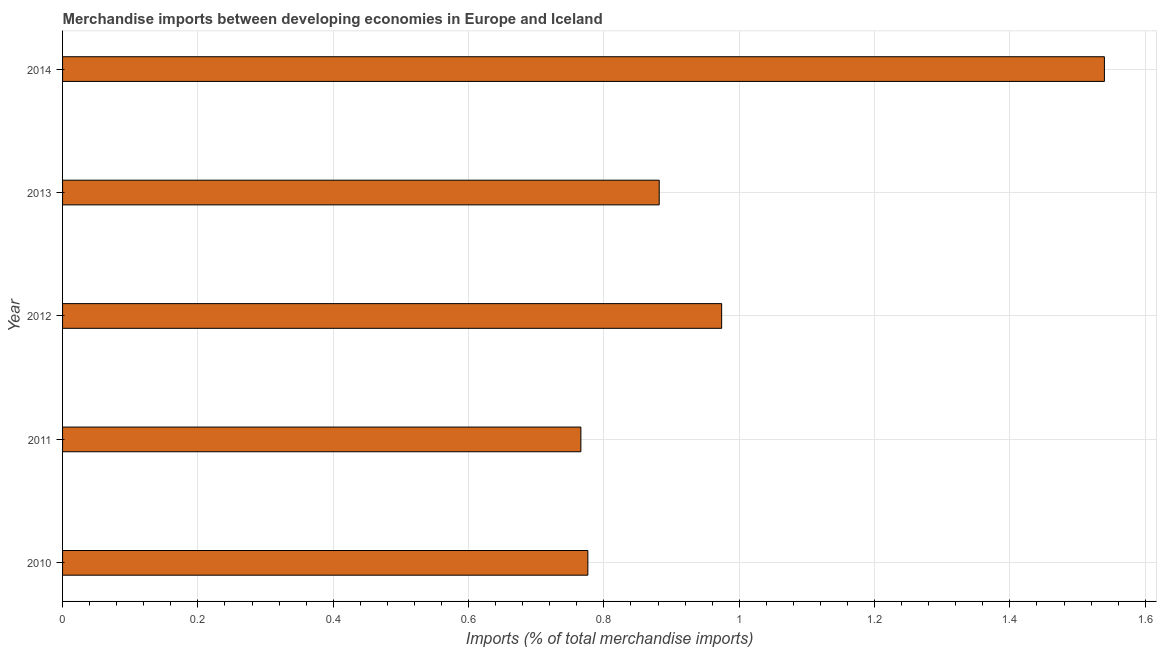What is the title of the graph?
Your answer should be compact. Merchandise imports between developing economies in Europe and Iceland. What is the label or title of the X-axis?
Offer a terse response. Imports (% of total merchandise imports). What is the label or title of the Y-axis?
Provide a succinct answer. Year. What is the merchandise imports in 2013?
Your answer should be very brief. 0.88. Across all years, what is the maximum merchandise imports?
Your response must be concise. 1.54. Across all years, what is the minimum merchandise imports?
Your answer should be compact. 0.77. In which year was the merchandise imports maximum?
Give a very brief answer. 2014. In which year was the merchandise imports minimum?
Your answer should be very brief. 2011. What is the sum of the merchandise imports?
Your answer should be compact. 4.94. What is the difference between the merchandise imports in 2011 and 2013?
Provide a short and direct response. -0.12. What is the median merchandise imports?
Your response must be concise. 0.88. In how many years, is the merchandise imports greater than 0.36 %?
Ensure brevity in your answer.  5. What is the ratio of the merchandise imports in 2011 to that in 2012?
Keep it short and to the point. 0.79. Is the merchandise imports in 2011 less than that in 2012?
Give a very brief answer. Yes. What is the difference between the highest and the second highest merchandise imports?
Your answer should be very brief. 0.57. What is the difference between the highest and the lowest merchandise imports?
Keep it short and to the point. 0.77. How many bars are there?
Ensure brevity in your answer.  5. Are all the bars in the graph horizontal?
Give a very brief answer. Yes. How many years are there in the graph?
Keep it short and to the point. 5. What is the difference between two consecutive major ticks on the X-axis?
Provide a short and direct response. 0.2. Are the values on the major ticks of X-axis written in scientific E-notation?
Keep it short and to the point. No. What is the Imports (% of total merchandise imports) in 2010?
Provide a succinct answer. 0.78. What is the Imports (% of total merchandise imports) of 2011?
Ensure brevity in your answer.  0.77. What is the Imports (% of total merchandise imports) of 2012?
Offer a very short reply. 0.97. What is the Imports (% of total merchandise imports) in 2013?
Offer a terse response. 0.88. What is the Imports (% of total merchandise imports) in 2014?
Offer a terse response. 1.54. What is the difference between the Imports (% of total merchandise imports) in 2010 and 2011?
Keep it short and to the point. 0.01. What is the difference between the Imports (% of total merchandise imports) in 2010 and 2012?
Make the answer very short. -0.2. What is the difference between the Imports (% of total merchandise imports) in 2010 and 2013?
Make the answer very short. -0.11. What is the difference between the Imports (% of total merchandise imports) in 2010 and 2014?
Your answer should be very brief. -0.76. What is the difference between the Imports (% of total merchandise imports) in 2011 and 2012?
Offer a very short reply. -0.21. What is the difference between the Imports (% of total merchandise imports) in 2011 and 2013?
Ensure brevity in your answer.  -0.12. What is the difference between the Imports (% of total merchandise imports) in 2011 and 2014?
Offer a terse response. -0.77. What is the difference between the Imports (% of total merchandise imports) in 2012 and 2013?
Your answer should be compact. 0.09. What is the difference between the Imports (% of total merchandise imports) in 2012 and 2014?
Provide a succinct answer. -0.57. What is the difference between the Imports (% of total merchandise imports) in 2013 and 2014?
Give a very brief answer. -0.66. What is the ratio of the Imports (% of total merchandise imports) in 2010 to that in 2011?
Ensure brevity in your answer.  1.01. What is the ratio of the Imports (% of total merchandise imports) in 2010 to that in 2012?
Provide a succinct answer. 0.8. What is the ratio of the Imports (% of total merchandise imports) in 2010 to that in 2014?
Your answer should be compact. 0.5. What is the ratio of the Imports (% of total merchandise imports) in 2011 to that in 2012?
Make the answer very short. 0.79. What is the ratio of the Imports (% of total merchandise imports) in 2011 to that in 2013?
Offer a very short reply. 0.87. What is the ratio of the Imports (% of total merchandise imports) in 2011 to that in 2014?
Offer a very short reply. 0.5. What is the ratio of the Imports (% of total merchandise imports) in 2012 to that in 2013?
Offer a terse response. 1.1. What is the ratio of the Imports (% of total merchandise imports) in 2012 to that in 2014?
Offer a very short reply. 0.63. What is the ratio of the Imports (% of total merchandise imports) in 2013 to that in 2014?
Your response must be concise. 0.57. 